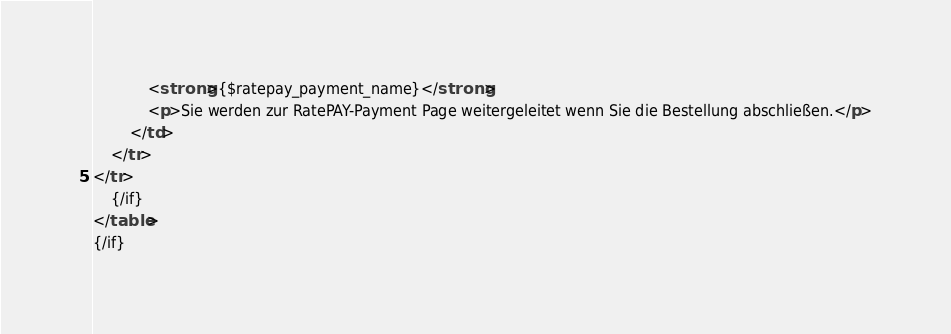Convert code to text. <code><loc_0><loc_0><loc_500><loc_500><_HTML_>            <strong>{$ratepay_payment_name}</strong>
            <p>Sie werden zur RatePAY-Payment Page weitergeleitet wenn Sie die Bestellung abschließen.</p>
        </td>
    </tr>
</tr>
    {/if}         
</table>
{/if}</code> 